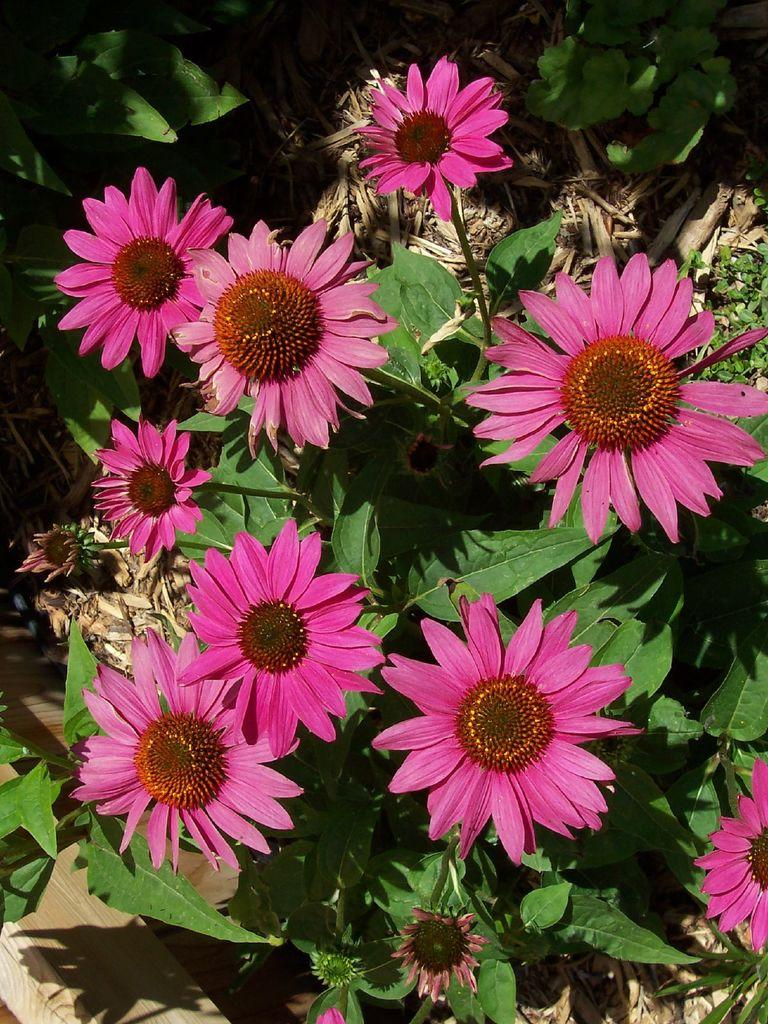What type of plants can be seen in the image? There are plants with flowers in the image. What material is visible in the image? Wood is visible in the image. What type of alley can be seen in the image? There is no alley present in the image. 